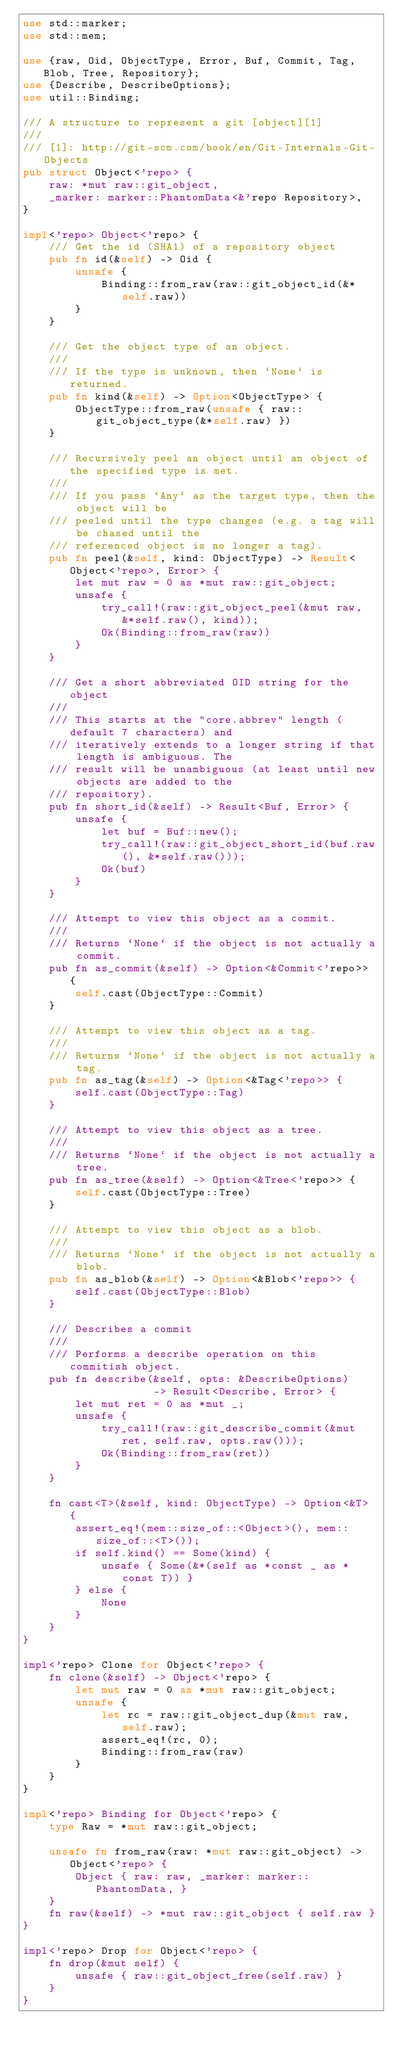<code> <loc_0><loc_0><loc_500><loc_500><_Rust_>use std::marker;
use std::mem;

use {raw, Oid, ObjectType, Error, Buf, Commit, Tag, Blob, Tree, Repository};
use {Describe, DescribeOptions};
use util::Binding;

/// A structure to represent a git [object][1]
///
/// [1]: http://git-scm.com/book/en/Git-Internals-Git-Objects
pub struct Object<'repo> {
    raw: *mut raw::git_object,
    _marker: marker::PhantomData<&'repo Repository>,
}

impl<'repo> Object<'repo> {
    /// Get the id (SHA1) of a repository object
    pub fn id(&self) -> Oid {
        unsafe {
            Binding::from_raw(raw::git_object_id(&*self.raw))
        }
    }

    /// Get the object type of an object.
    ///
    /// If the type is unknown, then `None` is returned.
    pub fn kind(&self) -> Option<ObjectType> {
        ObjectType::from_raw(unsafe { raw::git_object_type(&*self.raw) })
    }

    /// Recursively peel an object until an object of the specified type is met.
    ///
    /// If you pass `Any` as the target type, then the object will be
    /// peeled until the type changes (e.g. a tag will be chased until the
    /// referenced object is no longer a tag).
    pub fn peel(&self, kind: ObjectType) -> Result<Object<'repo>, Error> {
        let mut raw = 0 as *mut raw::git_object;
        unsafe {
            try_call!(raw::git_object_peel(&mut raw, &*self.raw(), kind));
            Ok(Binding::from_raw(raw))
        }
    }

    /// Get a short abbreviated OID string for the object
    ///
    /// This starts at the "core.abbrev" length (default 7 characters) and
    /// iteratively extends to a longer string if that length is ambiguous. The
    /// result will be unambiguous (at least until new objects are added to the
    /// repository).
    pub fn short_id(&self) -> Result<Buf, Error> {
        unsafe {
            let buf = Buf::new();
            try_call!(raw::git_object_short_id(buf.raw(), &*self.raw()));
            Ok(buf)
        }
    }

    /// Attempt to view this object as a commit.
    ///
    /// Returns `None` if the object is not actually a commit.
    pub fn as_commit(&self) -> Option<&Commit<'repo>> {
        self.cast(ObjectType::Commit)
    }

    /// Attempt to view this object as a tag.
    ///
    /// Returns `None` if the object is not actually a tag.
    pub fn as_tag(&self) -> Option<&Tag<'repo>> {
        self.cast(ObjectType::Tag)
    }

    /// Attempt to view this object as a tree.
    ///
    /// Returns `None` if the object is not actually a tree.
    pub fn as_tree(&self) -> Option<&Tree<'repo>> {
        self.cast(ObjectType::Tree)
    }

    /// Attempt to view this object as a blob.
    ///
    /// Returns `None` if the object is not actually a blob.
    pub fn as_blob(&self) -> Option<&Blob<'repo>> {
        self.cast(ObjectType::Blob)
    }

    /// Describes a commit
    ///
    /// Performs a describe operation on this commitish object.
    pub fn describe(&self, opts: &DescribeOptions)
                    -> Result<Describe, Error> {
        let mut ret = 0 as *mut _;
        unsafe {
            try_call!(raw::git_describe_commit(&mut ret, self.raw, opts.raw()));
            Ok(Binding::from_raw(ret))
        }
    }

    fn cast<T>(&self, kind: ObjectType) -> Option<&T> {
        assert_eq!(mem::size_of::<Object>(), mem::size_of::<T>());
        if self.kind() == Some(kind) {
            unsafe { Some(&*(self as *const _ as *const T)) }
        } else {
            None
        }
    }
}

impl<'repo> Clone for Object<'repo> {
    fn clone(&self) -> Object<'repo> {
        let mut raw = 0 as *mut raw::git_object;
        unsafe {
            let rc = raw::git_object_dup(&mut raw, self.raw);
            assert_eq!(rc, 0);
            Binding::from_raw(raw)
        }
    }
}

impl<'repo> Binding for Object<'repo> {
    type Raw = *mut raw::git_object;

    unsafe fn from_raw(raw: *mut raw::git_object) -> Object<'repo> {
        Object { raw: raw, _marker: marker::PhantomData, }
    }
    fn raw(&self) -> *mut raw::git_object { self.raw }
}

impl<'repo> Drop for Object<'repo> {
    fn drop(&mut self) {
        unsafe { raw::git_object_free(self.raw) }
    }
}
</code> 